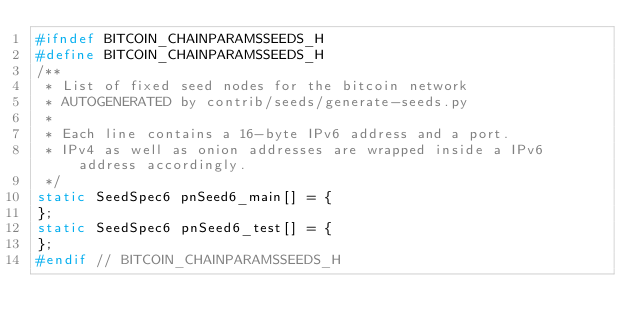<code> <loc_0><loc_0><loc_500><loc_500><_C_>#ifndef BITCOIN_CHAINPARAMSSEEDS_H
#define BITCOIN_CHAINPARAMSSEEDS_H
/**
 * List of fixed seed nodes for the bitcoin network
 * AUTOGENERATED by contrib/seeds/generate-seeds.py
 *
 * Each line contains a 16-byte IPv6 address and a port.
 * IPv4 as well as onion addresses are wrapped inside a IPv6 address accordingly.
 */
static SeedSpec6 pnSeed6_main[] = {
};
static SeedSpec6 pnSeed6_test[] = {
};
#endif // BITCOIN_CHAINPARAMSSEEDS_H
</code> 